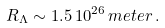<formula> <loc_0><loc_0><loc_500><loc_500>R _ { \Lambda } \sim 1 . 5 \, 1 0 ^ { 2 6 } \, m e t e r \, .</formula> 